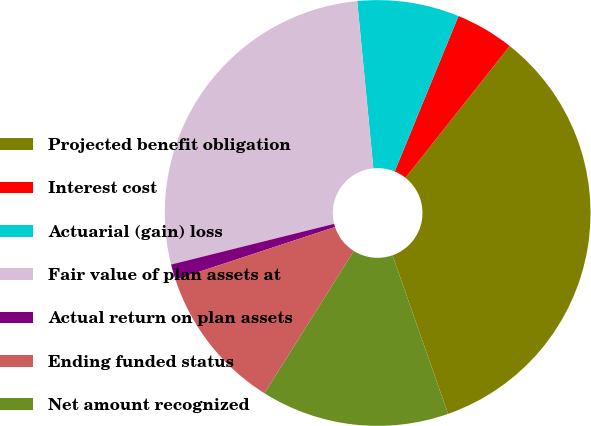<chart> <loc_0><loc_0><loc_500><loc_500><pie_chart><fcel>Projected benefit obligation<fcel>Interest cost<fcel>Actuarial (gain) loss<fcel>Fair value of plan assets at<fcel>Actual return on plan assets<fcel>Ending funded status<fcel>Net amount recognized<nl><fcel>33.98%<fcel>4.45%<fcel>7.73%<fcel>27.36%<fcel>1.17%<fcel>11.01%<fcel>14.29%<nl></chart> 